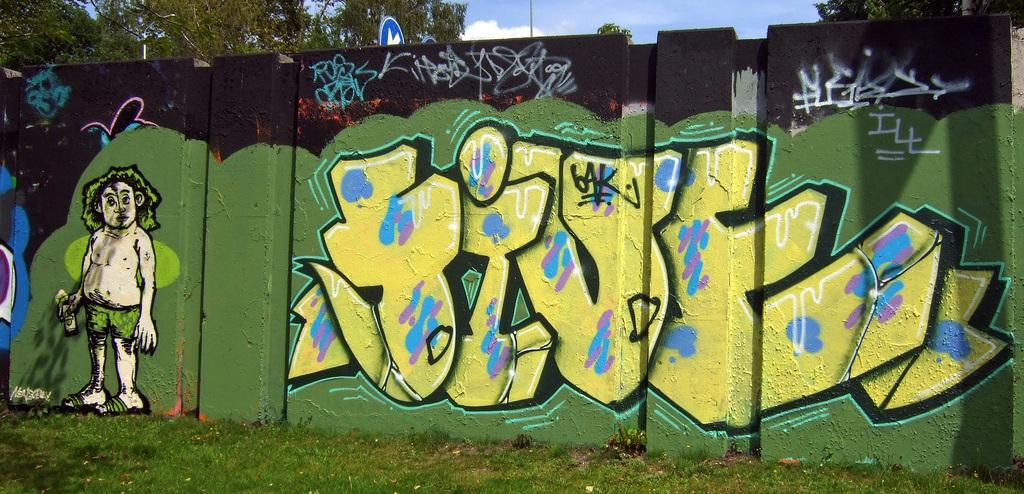What is present on the wall in the image? There is a painting on the wall in the image. What can be seen at the top of the image? The sky is visible at the top of the image. What type of vegetation is present in the image? There are trees in the image. Can you tell me how many friends are depicted in the painting on the wall? There is no information about friends in the image, as the focus is on the wall, painting, sky, and trees. 